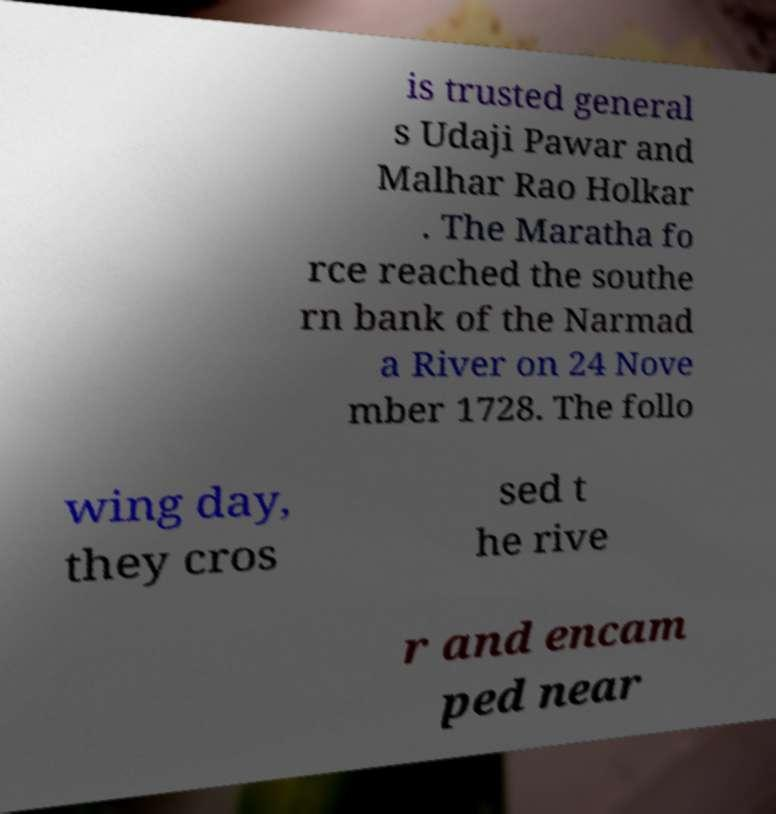I need the written content from this picture converted into text. Can you do that? is trusted general s Udaji Pawar and Malhar Rao Holkar . The Maratha fo rce reached the southe rn bank of the Narmad a River on 24 Nove mber 1728. The follo wing day, they cros sed t he rive r and encam ped near 